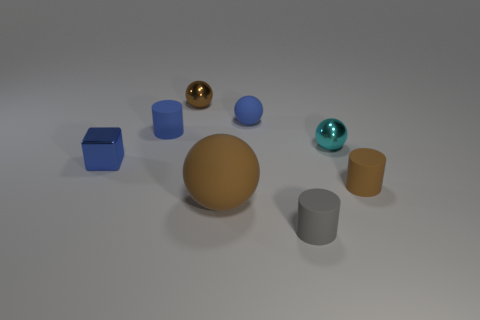Is there a blue object of the same size as the brown cylinder?
Your answer should be very brief. Yes. There is a tiny shiny ball in front of the small blue matte sphere; is its color the same as the tiny metal cube?
Ensure brevity in your answer.  No. How big is the brown shiny object?
Offer a very short reply. Small. There is a brown matte ball in front of the metal ball left of the cyan thing; what is its size?
Ensure brevity in your answer.  Large. How many large objects have the same color as the tiny cube?
Provide a short and direct response. 0. What number of blue rubber cylinders are there?
Your answer should be compact. 1. What number of small brown spheres are the same material as the cyan ball?
Provide a short and direct response. 1. The other metallic object that is the same shape as the cyan object is what size?
Ensure brevity in your answer.  Small. What is the material of the blue cube?
Ensure brevity in your answer.  Metal. There is a brown thing that is to the right of the brown rubber object that is left of the matte sphere that is behind the blue rubber cylinder; what is its material?
Your answer should be very brief. Rubber. 